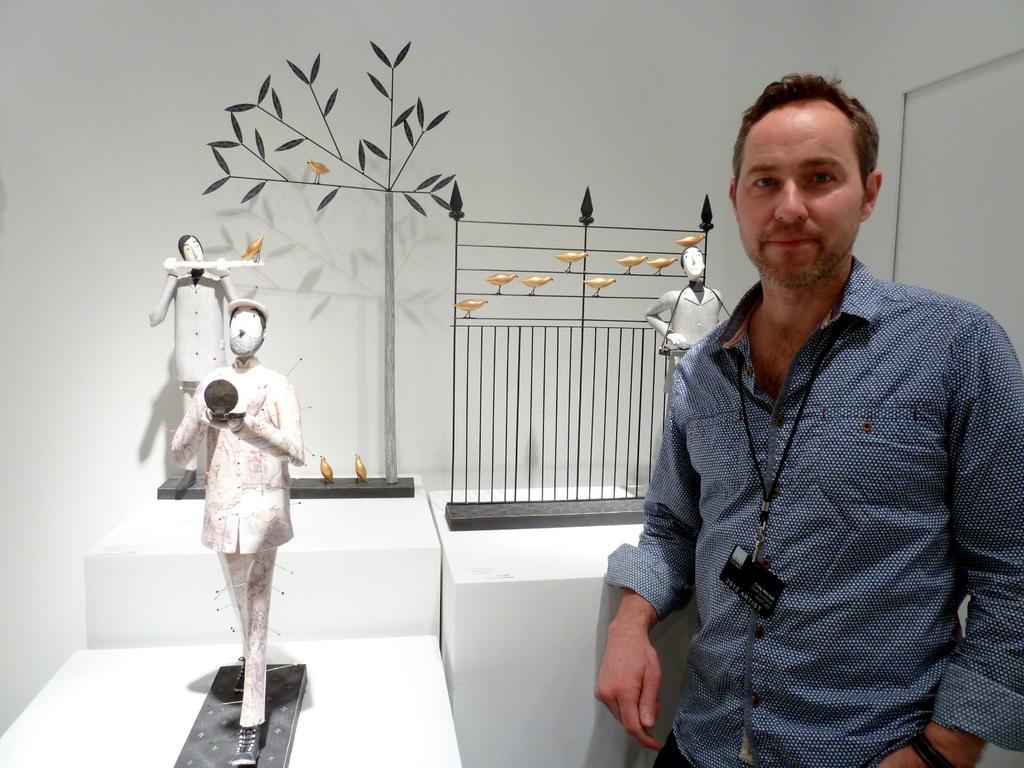In one or two sentences, can you explain what this image depicts? In this picture I can see there is a man standing on the right side and he is wearing an ID card and a shirt. There are statues of few people and there are few birds. In the backdrop there is a wall. 